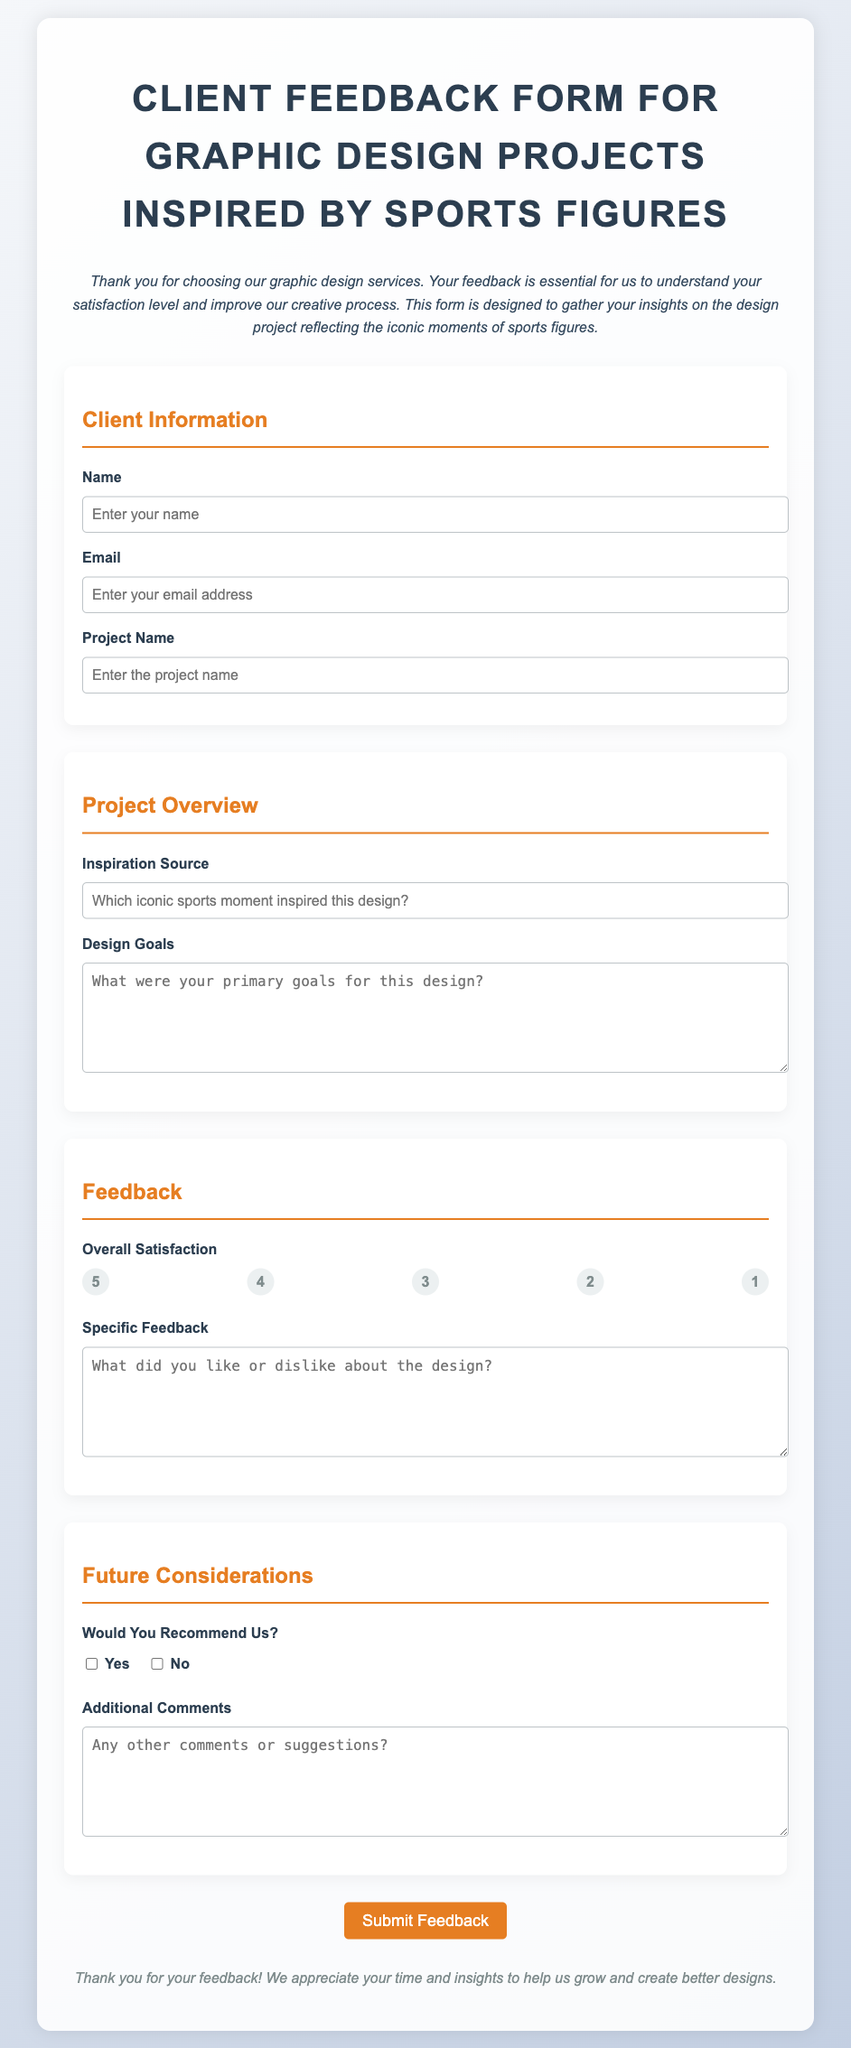What is the title of the document? The title is mentioned in the header section of the document.
Answer: Client Feedback Form for Graphic Design Projects Inspired by Sports Figures What color is the button for submitting feedback? The button's color is specified in the inline style of the submit element.
Answer: Orange Which section discusses client information? The section for client information is specifically labeled in the document.
Answer: Client Information What prompt requires the source of inspiration? This prompt is specified under the Project Overview section.
Answer: Inspiration Source What is the maximum width of the container in the document? The maximum width is defined in the CSS style for the container element.
Answer: 800px What is the main theme of the designs being evaluated? The main theme is related to the subject matter presented in the introduction paragraph.
Answer: Sports figures How many rating options are provided in the feedback section? The number of rating options is indicated by the radio buttons available to users.
Answer: 5 What type of comments can be added in the Additional Comments section? This section allows for general feedback and suggestions which is highlighted in the document.
Answer: Any other comments or suggestions Would the feedback form allow you to indicate a recommendation? This is explicitly stated in the Future Considerations section of the form.
Answer: Yes/No 